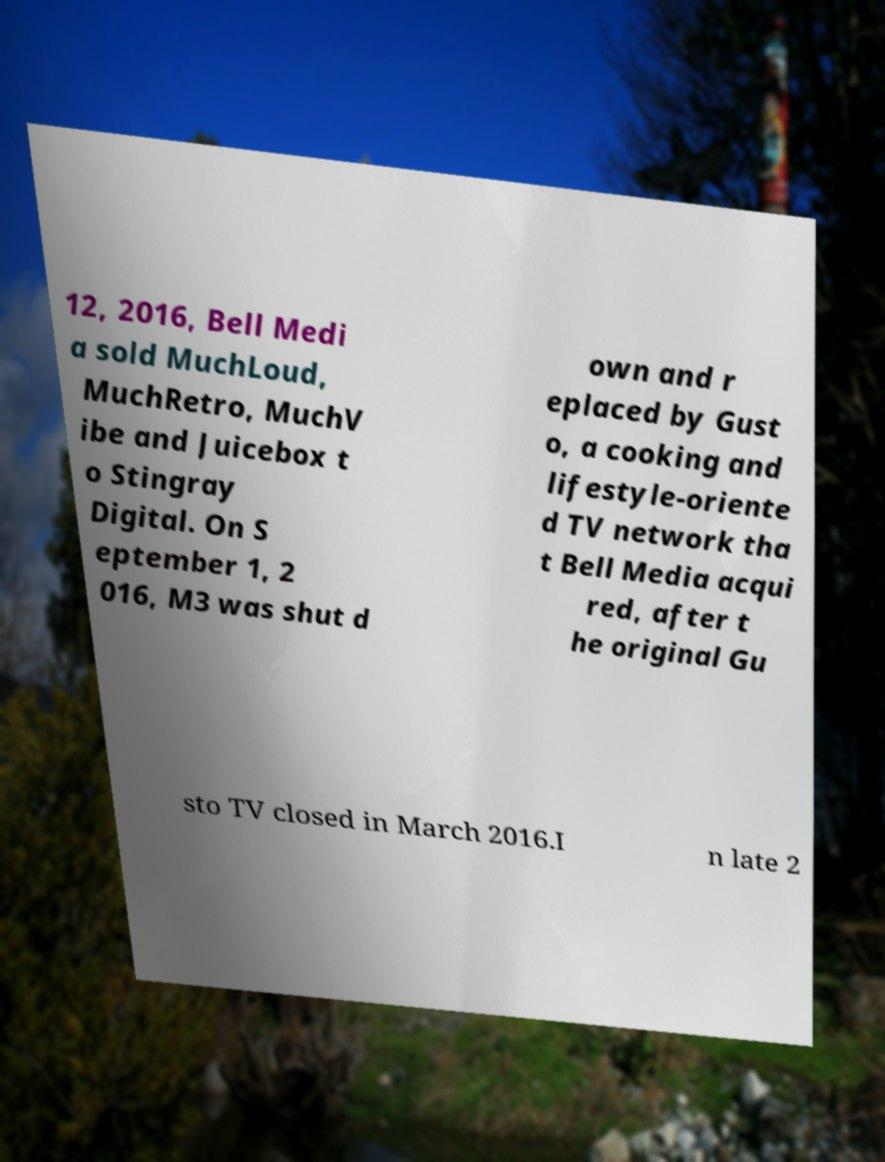Can you read and provide the text displayed in the image?This photo seems to have some interesting text. Can you extract and type it out for me? 12, 2016, Bell Medi a sold MuchLoud, MuchRetro, MuchV ibe and Juicebox t o Stingray Digital. On S eptember 1, 2 016, M3 was shut d own and r eplaced by Gust o, a cooking and lifestyle-oriente d TV network tha t Bell Media acqui red, after t he original Gu sto TV closed in March 2016.I n late 2 